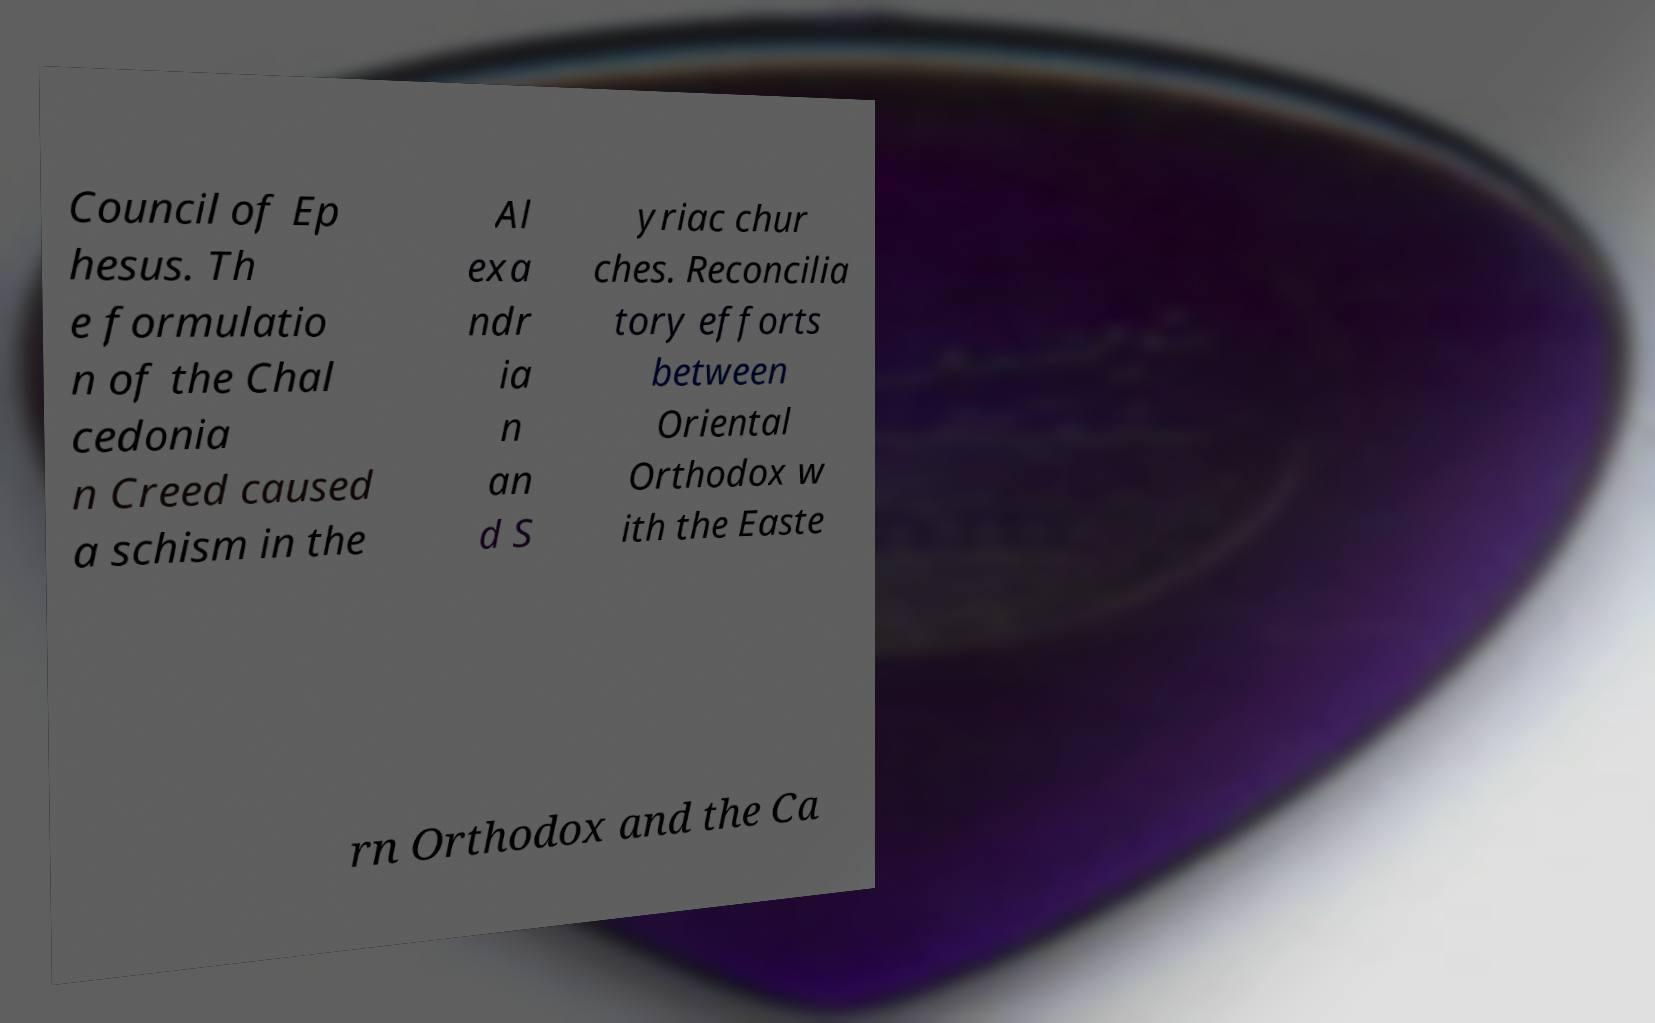I need the written content from this picture converted into text. Can you do that? Council of Ep hesus. Th e formulatio n of the Chal cedonia n Creed caused a schism in the Al exa ndr ia n an d S yriac chur ches. Reconcilia tory efforts between Oriental Orthodox w ith the Easte rn Orthodox and the Ca 